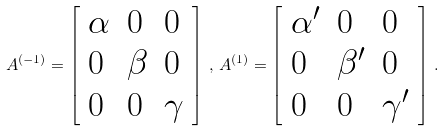Convert formula to latex. <formula><loc_0><loc_0><loc_500><loc_500>A ^ { ( - 1 ) } = \left [ \begin{array} { l l l } \alpha & 0 & 0 \\ 0 & \beta & 0 \\ 0 & 0 & \gamma \end{array} \right ] \, , \, A ^ { ( 1 ) } = \left [ \begin{array} { l l l } \alpha ^ { \prime } & 0 & 0 \\ 0 & \beta ^ { \prime } & 0 \\ 0 & 0 & \gamma ^ { \prime } \end{array} \right ] \, .</formula> 